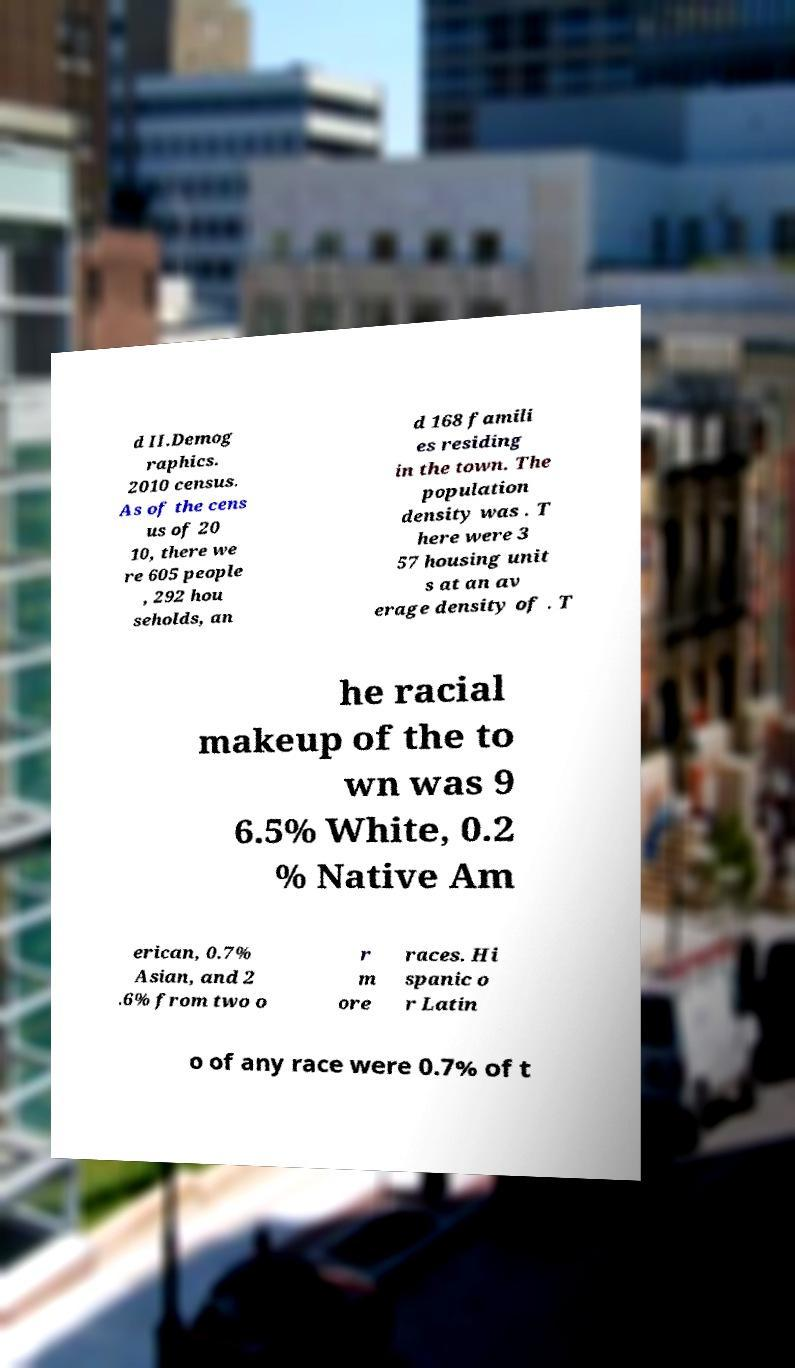What messages or text are displayed in this image? I need them in a readable, typed format. d II.Demog raphics. 2010 census. As of the cens us of 20 10, there we re 605 people , 292 hou seholds, an d 168 famili es residing in the town. The population density was . T here were 3 57 housing unit s at an av erage density of . T he racial makeup of the to wn was 9 6.5% White, 0.2 % Native Am erican, 0.7% Asian, and 2 .6% from two o r m ore races. Hi spanic o r Latin o of any race were 0.7% of t 